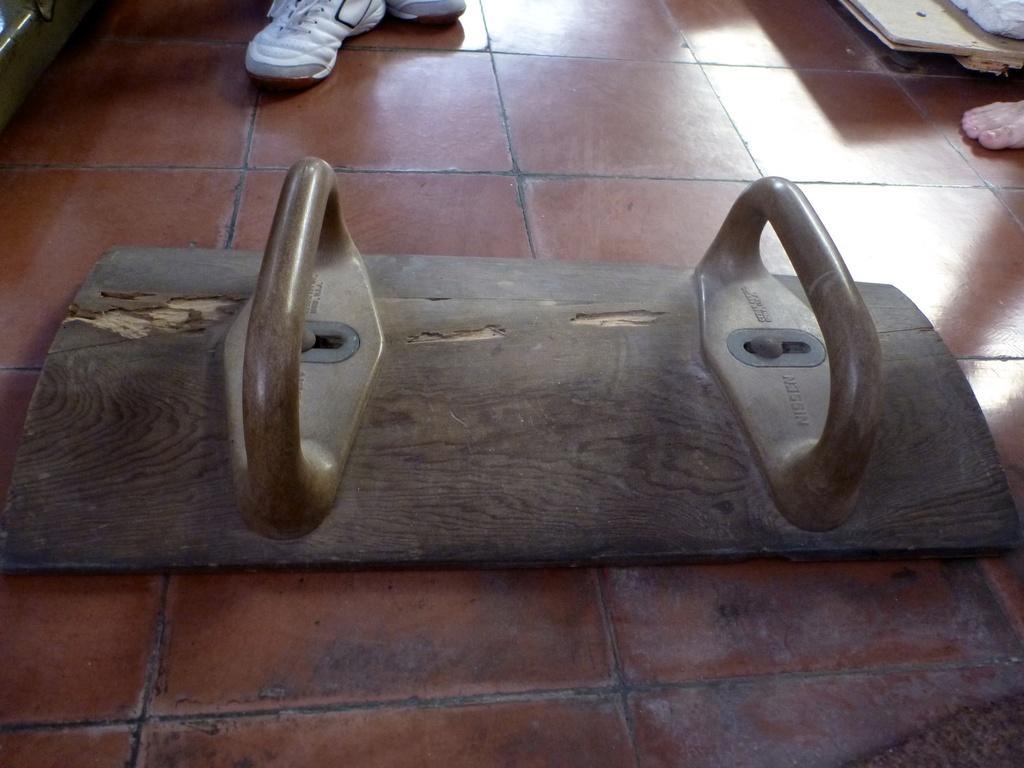In one or two sentences, can you explain what this image depicts? This picture shows wooden plank with handles to hold on the floor and we see human legs with shoes and another human leg. 